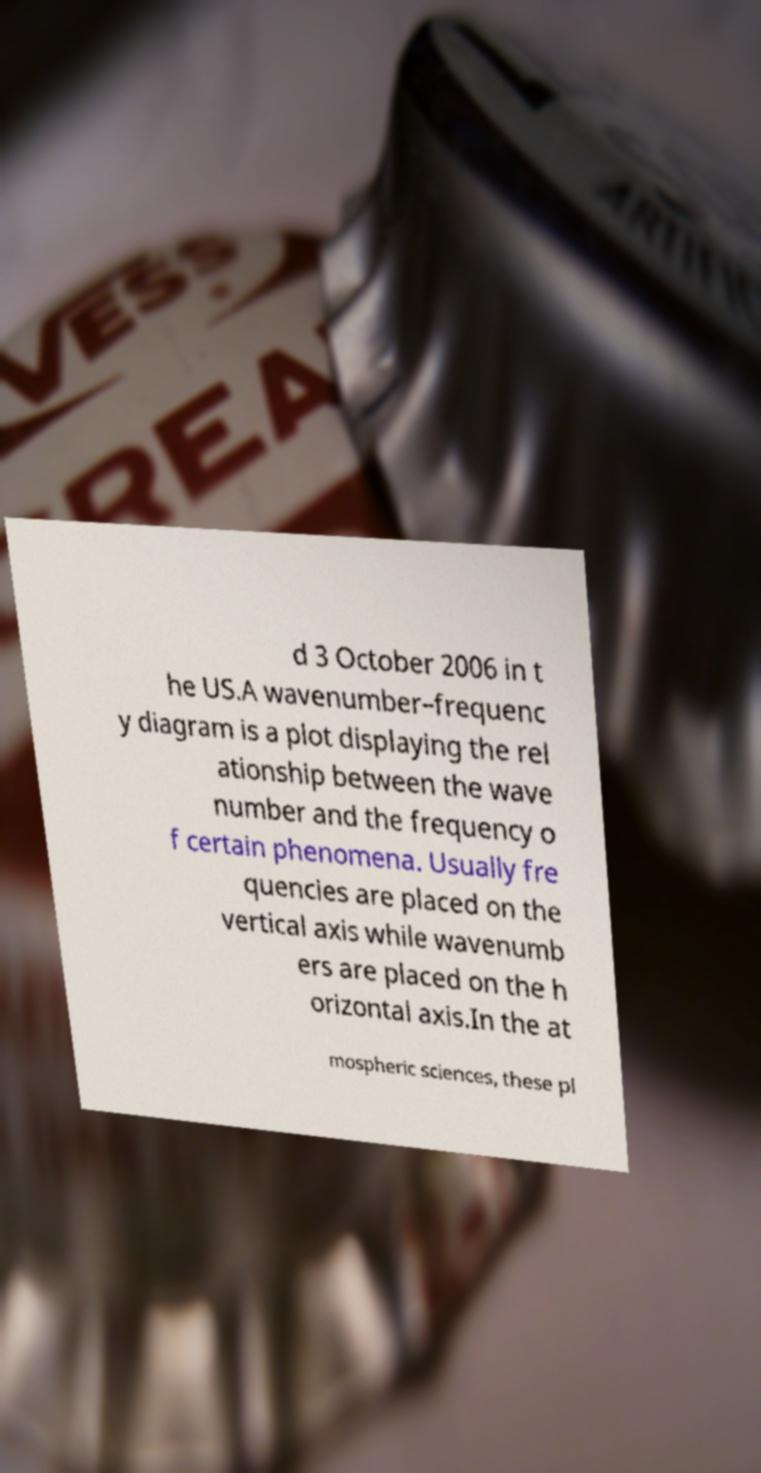Could you extract and type out the text from this image? d 3 October 2006 in t he US.A wavenumber–frequenc y diagram is a plot displaying the rel ationship between the wave number and the frequency o f certain phenomena. Usually fre quencies are placed on the vertical axis while wavenumb ers are placed on the h orizontal axis.In the at mospheric sciences, these pl 